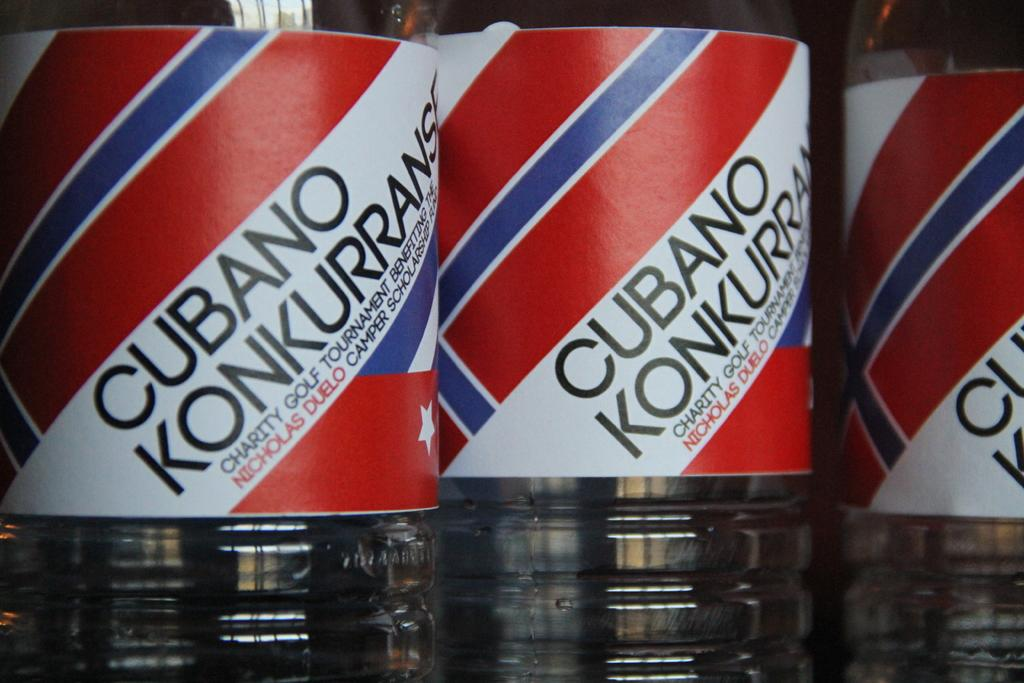<image>
Give a short and clear explanation of the subsequent image. Three bottles of Cubano Konkurrans sit next to each other. 